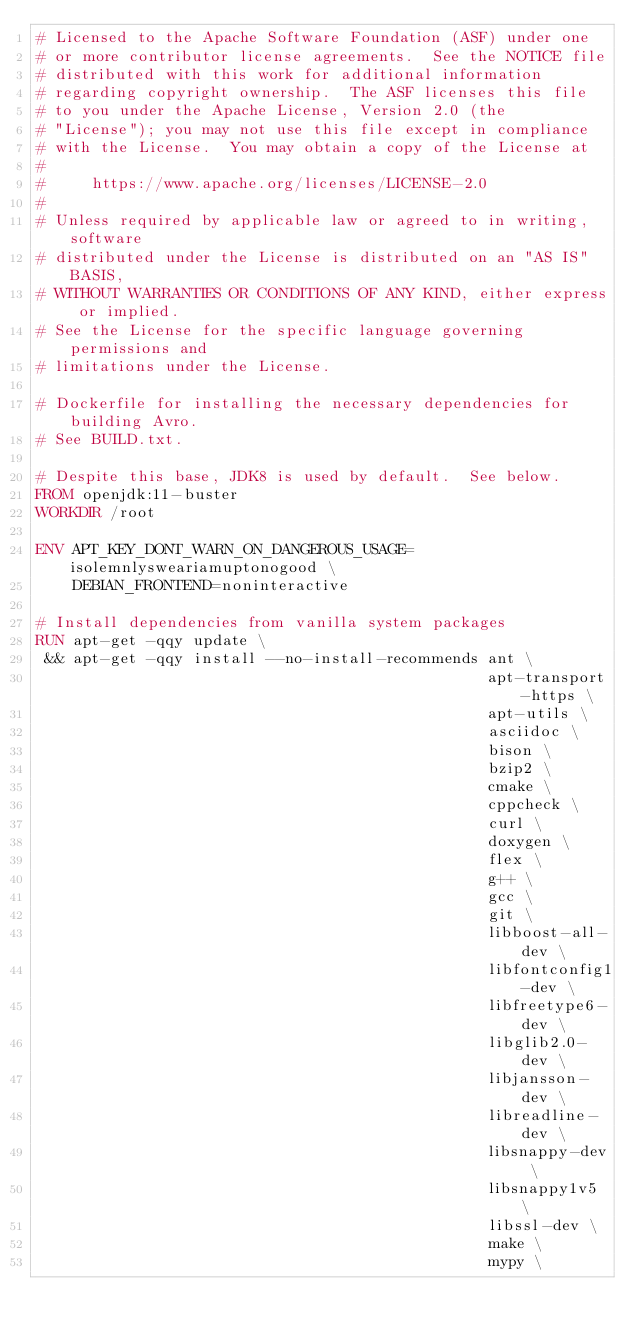Convert code to text. <code><loc_0><loc_0><loc_500><loc_500><_Dockerfile_># Licensed to the Apache Software Foundation (ASF) under one
# or more contributor license agreements.  See the NOTICE file
# distributed with this work for additional information
# regarding copyright ownership.  The ASF licenses this file
# to you under the Apache License, Version 2.0 (the
# "License"); you may not use this file except in compliance
# with the License.  You may obtain a copy of the License at
#
#     https://www.apache.org/licenses/LICENSE-2.0
#
# Unless required by applicable law or agreed to in writing, software
# distributed under the License is distributed on an "AS IS" BASIS,
# WITHOUT WARRANTIES OR CONDITIONS OF ANY KIND, either express or implied.
# See the License for the specific language governing permissions and
# limitations under the License.

# Dockerfile for installing the necessary dependencies for building Avro.
# See BUILD.txt.

# Despite this base, JDK8 is used by default.  See below.
FROM openjdk:11-buster
WORKDIR /root

ENV APT_KEY_DONT_WARN_ON_DANGEROUS_USAGE=isolemnlysweariamuptonogood \
    DEBIAN_FRONTEND=noninteractive

# Install dependencies from vanilla system packages
RUN apt-get -qqy update \
 && apt-get -qqy install --no-install-recommends ant \
                                                 apt-transport-https \
                                                 apt-utils \
                                                 asciidoc \
                                                 bison \
                                                 bzip2 \
                                                 cmake \
                                                 cppcheck \
                                                 curl \
                                                 doxygen \
                                                 flex \
                                                 g++ \
                                                 gcc \
                                                 git \
                                                 libboost-all-dev \
                                                 libfontconfig1-dev \
                                                 libfreetype6-dev \
                                                 libglib2.0-dev \
                                                 libjansson-dev \
                                                 libreadline-dev \
                                                 libsnappy-dev \
                                                 libsnappy1v5 \
                                                 libssl-dev \
                                                 make \
                                                 mypy \</code> 